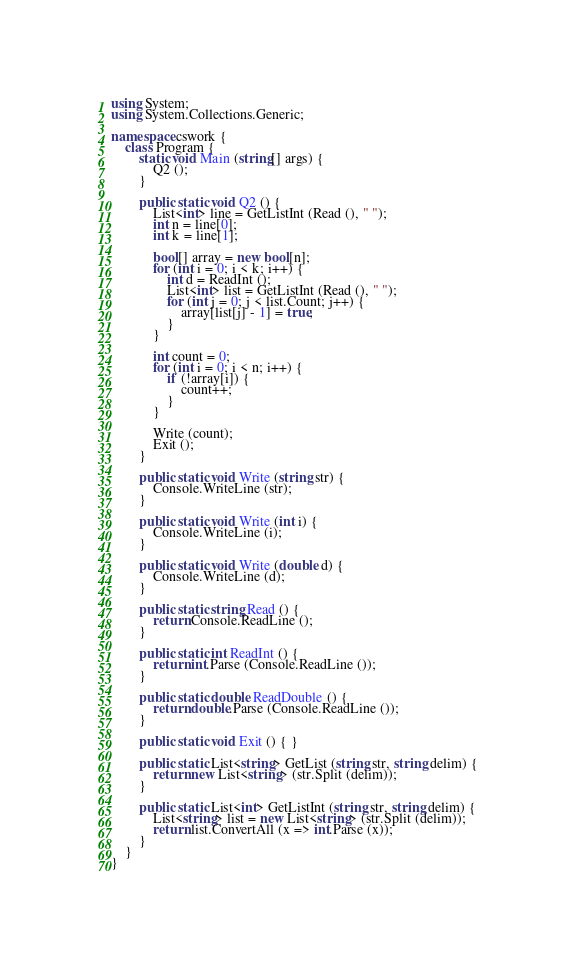Convert code to text. <code><loc_0><loc_0><loc_500><loc_500><_C#_>using System;
using System.Collections.Generic;

namespace cswork {
    class Program {
        static void Main (string[] args) {
            Q2 ();
        }

        public static void Q2 () {
            List<int> line = GetListInt (Read (), " ");
            int n = line[0];
            int k = line[1];

            bool[] array = new bool[n];
            for (int i = 0; i < k; i++) {
                int d = ReadInt ();
                List<int> list = GetListInt (Read (), " ");
                for (int j = 0; j < list.Count; j++) {
                    array[list[j] - 1] = true;
                }
            }

            int count = 0;
            for (int i = 0; i < n; i++) {
                if (!array[i]) {
                    count++;
                }
            }

            Write (count);
            Exit ();
        }

        public static void Write (string str) {
            Console.WriteLine (str);
        }

        public static void Write (int i) {
            Console.WriteLine (i);
        }

        public static void Write (double d) {
            Console.WriteLine (d);
        }

        public static string Read () {
            return Console.ReadLine ();
        }

        public static int ReadInt () {
            return int.Parse (Console.ReadLine ());
        }

        public static double ReadDouble () {
            return double.Parse (Console.ReadLine ());
        }

        public static void Exit () { }

        public static List<string> GetList (string str, string delim) {
            return new List<string> (str.Split (delim));
        }

        public static List<int> GetListInt (string str, string delim) {
            List<string> list = new List<string> (str.Split (delim));
            return list.ConvertAll (x => int.Parse (x));
        }
    }
}</code> 